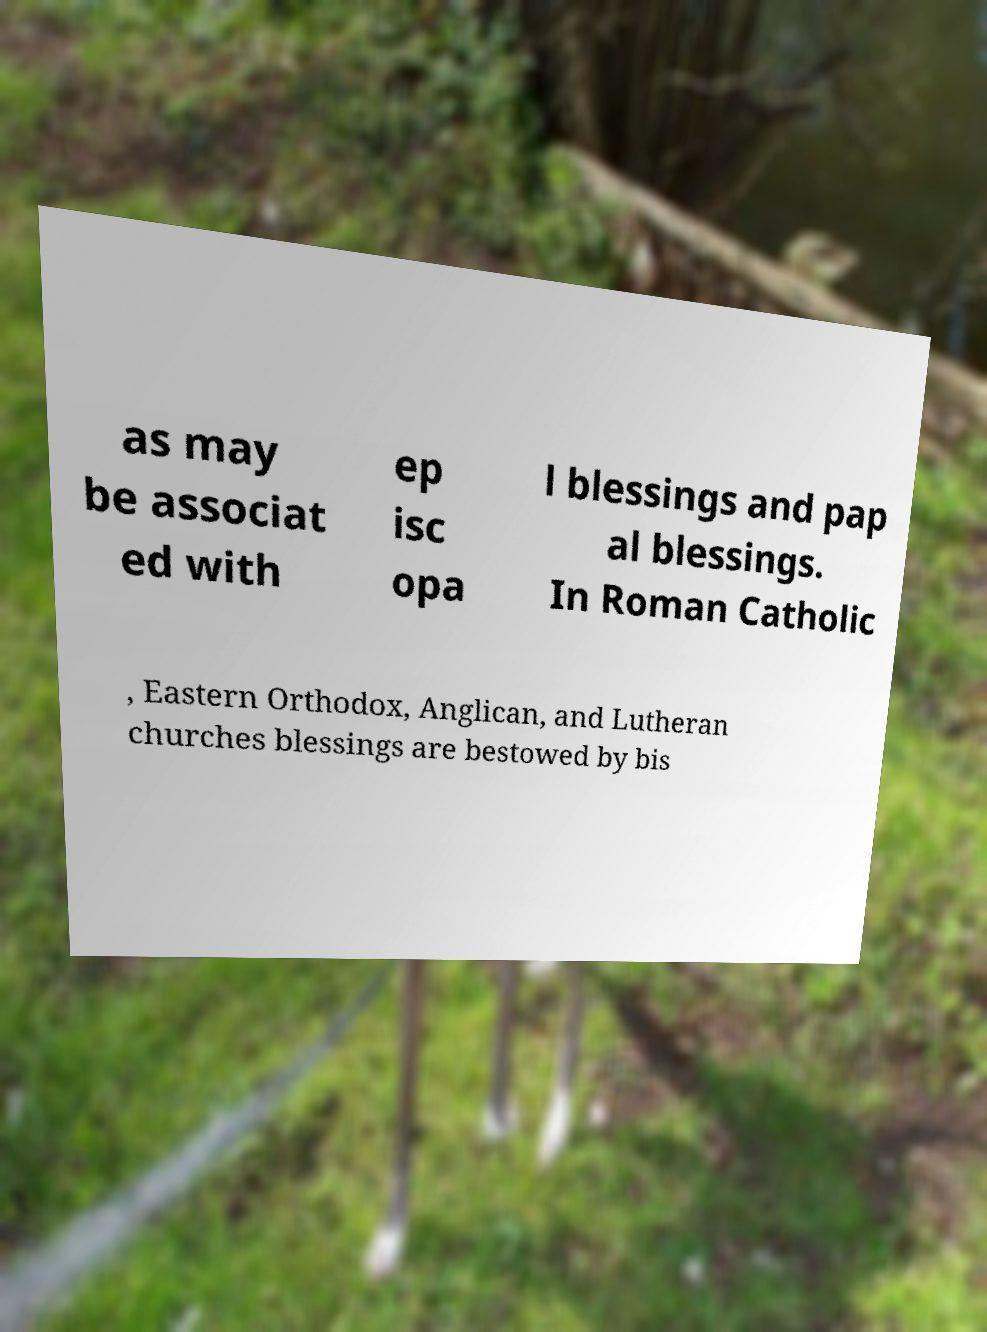For documentation purposes, I need the text within this image transcribed. Could you provide that? as may be associat ed with ep isc opa l blessings and pap al blessings. In Roman Catholic , Eastern Orthodox, Anglican, and Lutheran churches blessings are bestowed by bis 